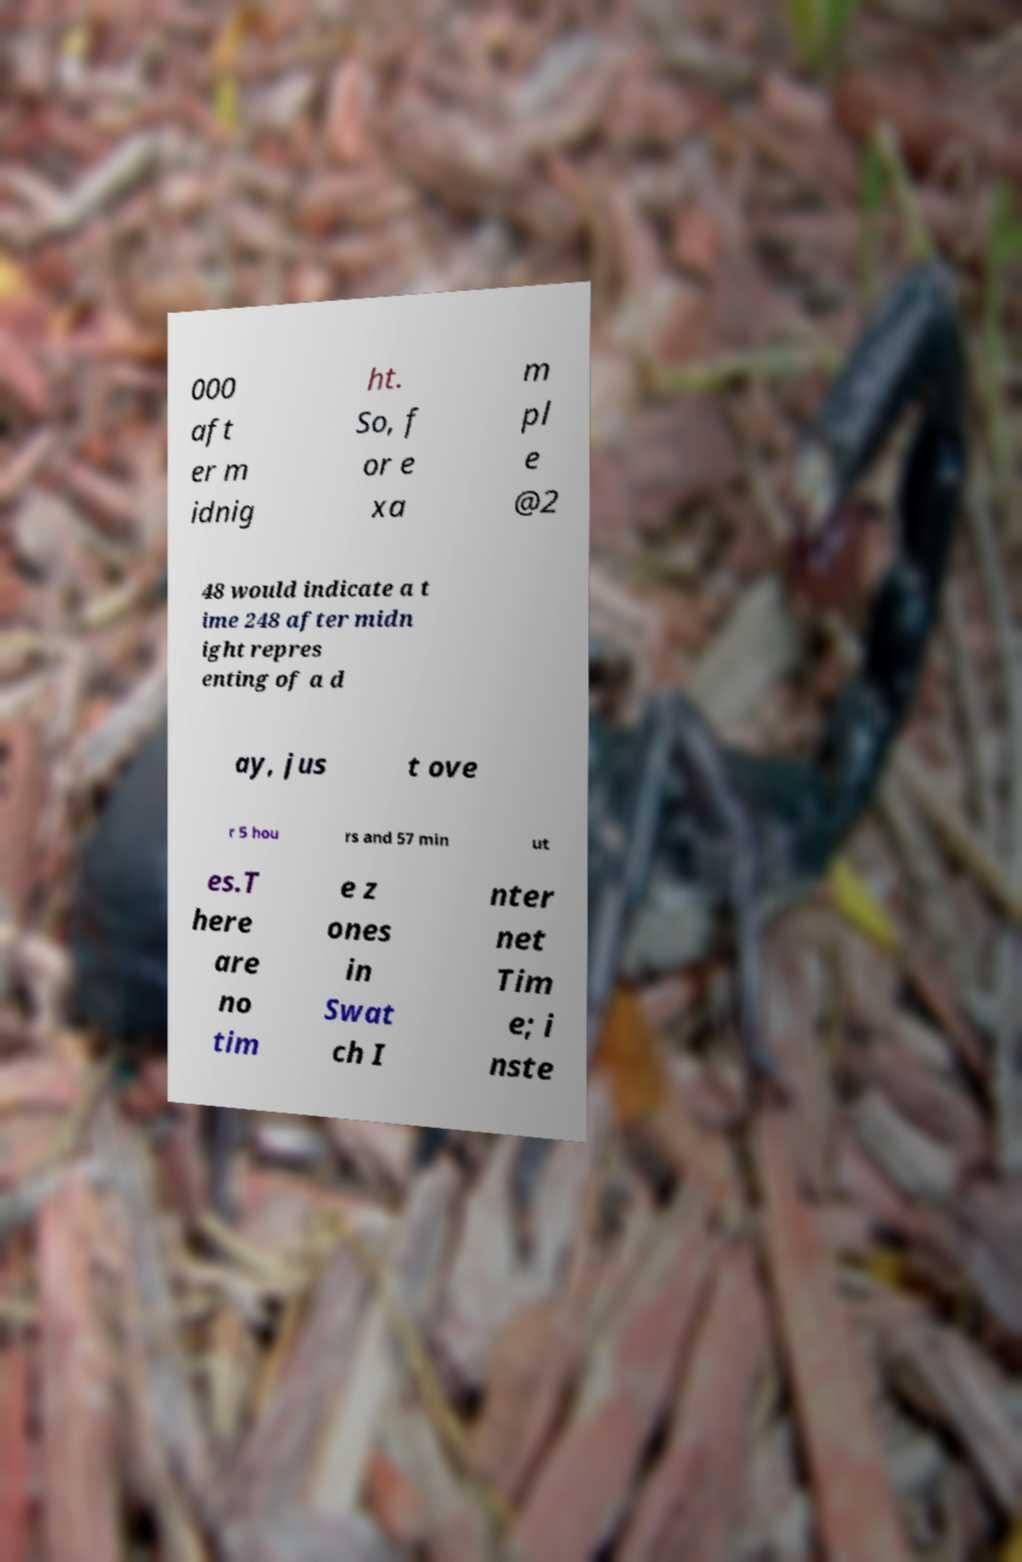Can you read and provide the text displayed in the image?This photo seems to have some interesting text. Can you extract and type it out for me? 000 aft er m idnig ht. So, f or e xa m pl e @2 48 would indicate a t ime 248 after midn ight repres enting of a d ay, jus t ove r 5 hou rs and 57 min ut es.T here are no tim e z ones in Swat ch I nter net Tim e; i nste 